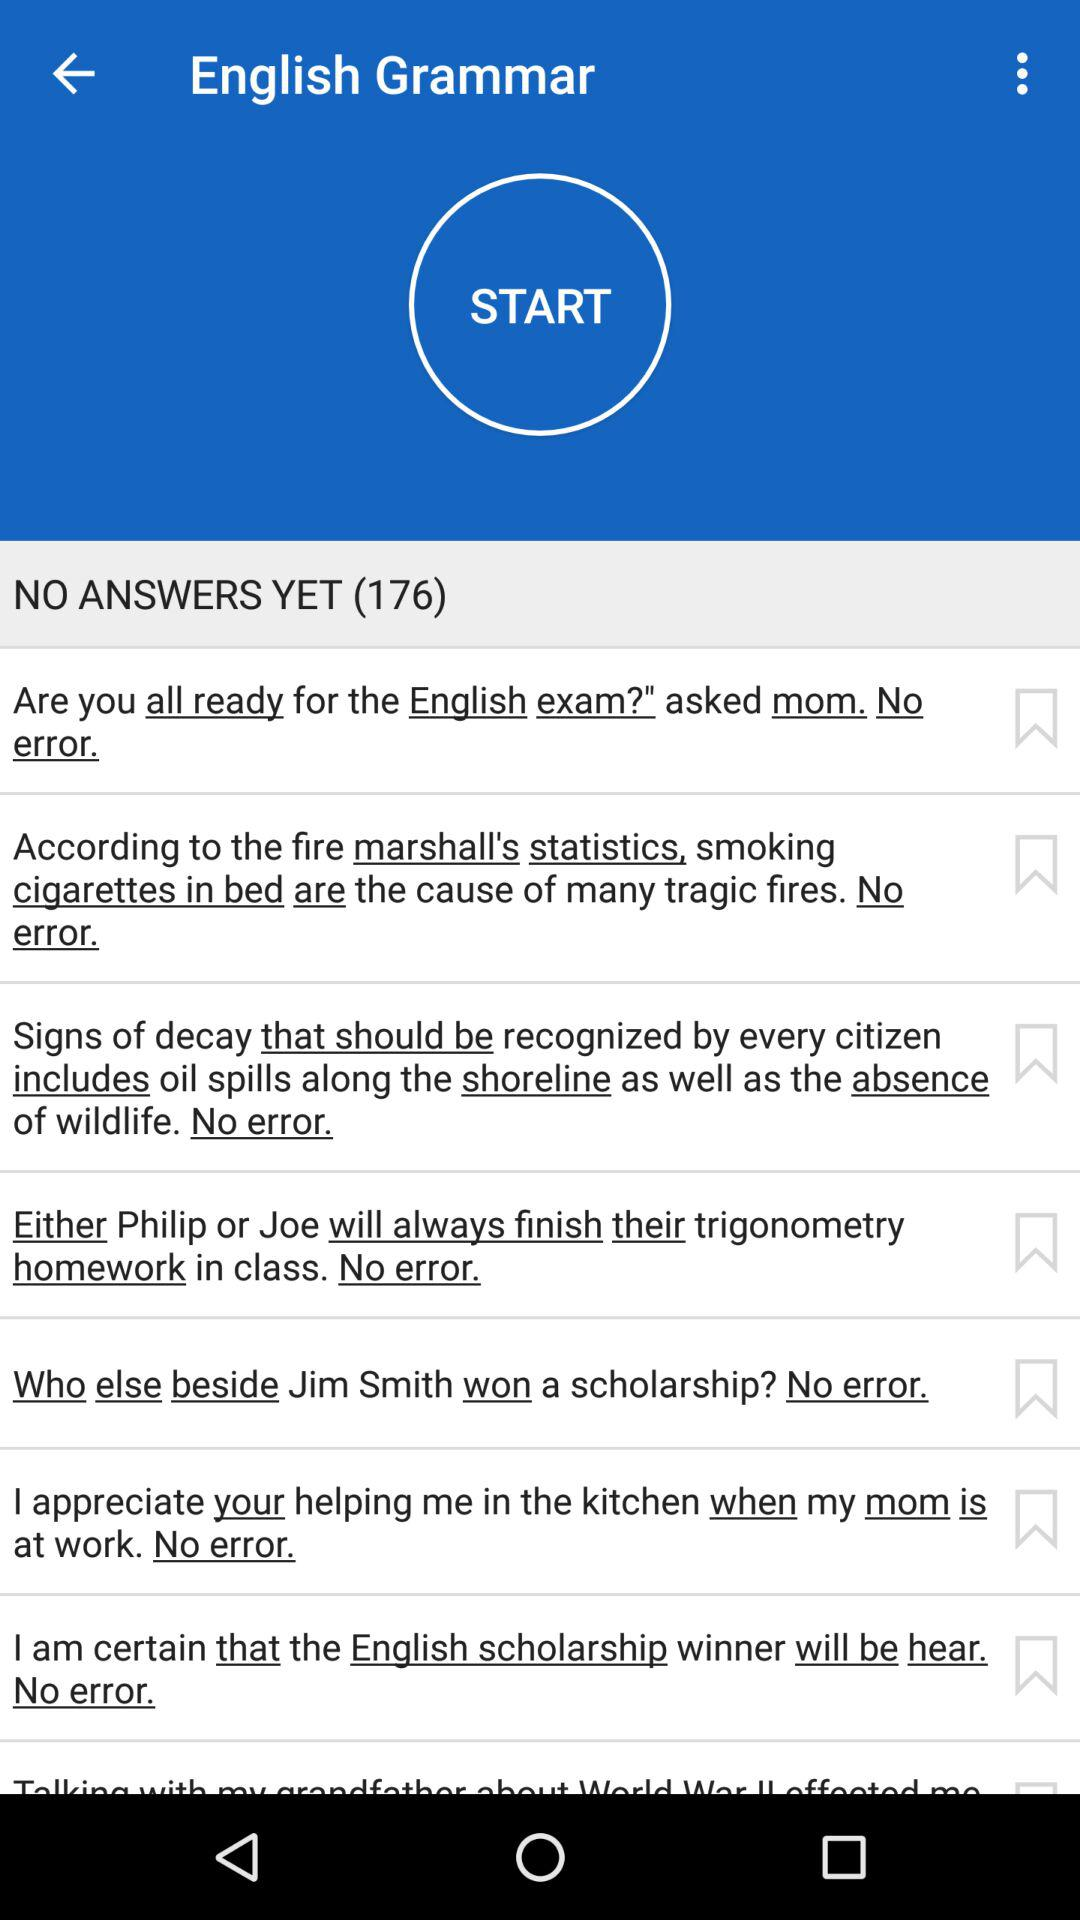What's the count of answers not given yet? The count of answers not given yet is 176. 